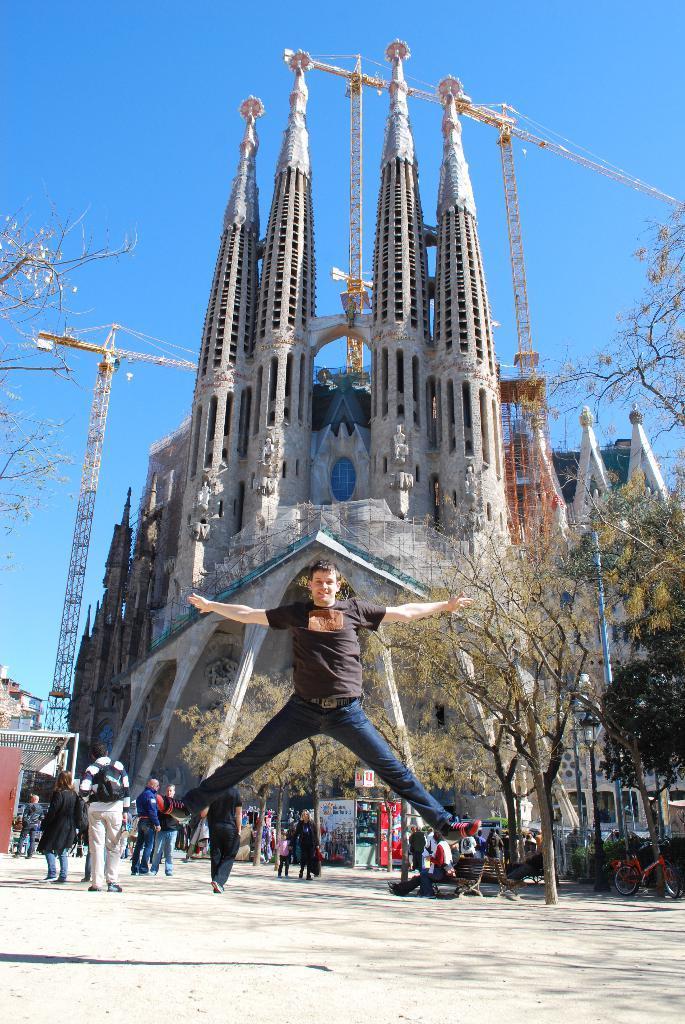In one or two sentences, can you explain what this image depicts? In this image I can see few building, castle, trees, cranes, few people, stores and few bicycles. I can see few people are sitting on bench. The sky is in blue color. 